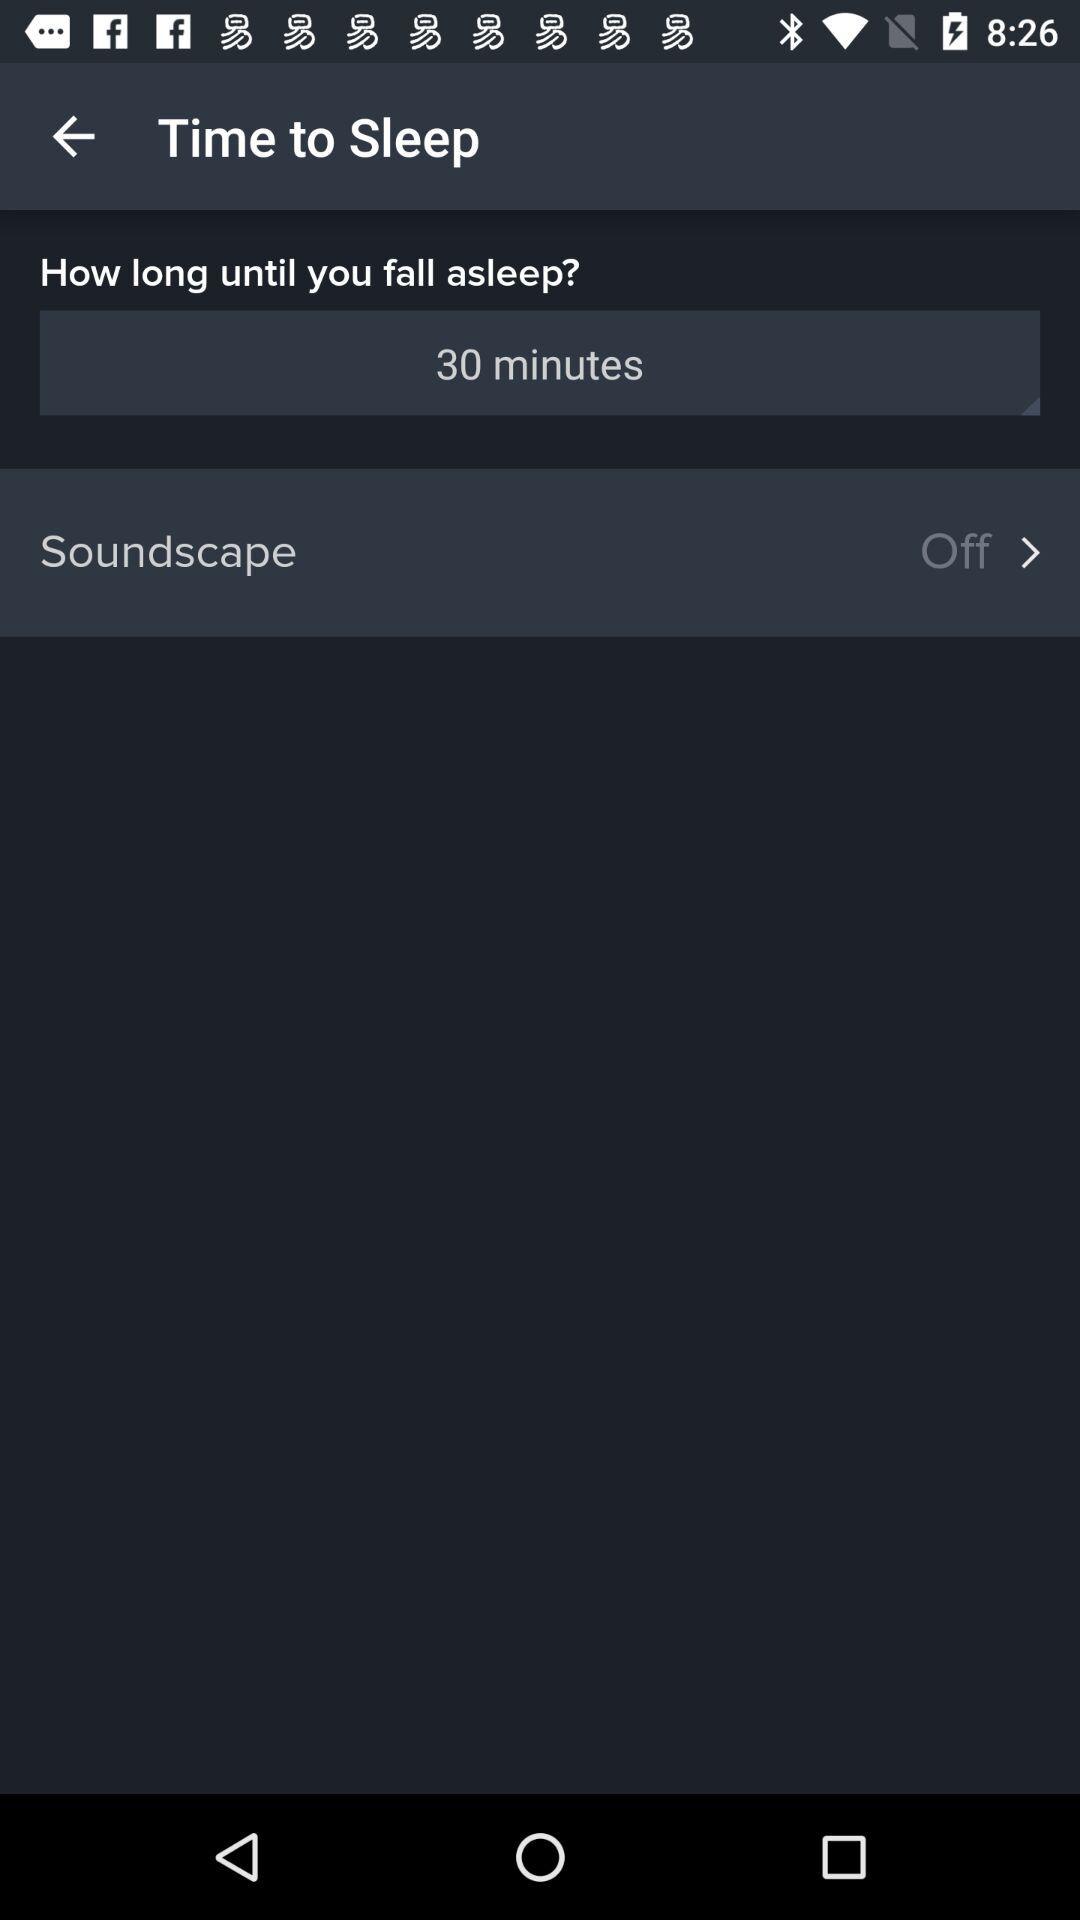Is "Soundscape" on or off?
Answer the question using a single word or phrase. "Soundscape" is "off". 